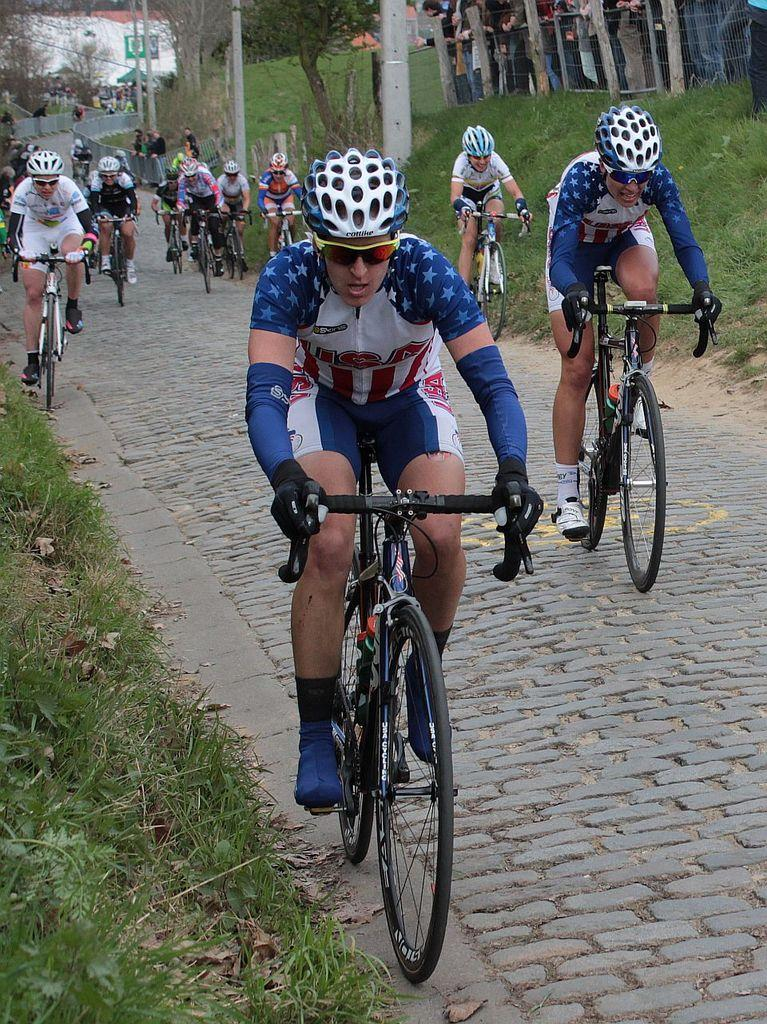How many people are in the image? There are people in the image, but the exact number is not specified. What are some of the people doing in the image? Some people are riding bicycles in the image. What can be seen in the image besides the people and bicycles? There are poles, sign boards, grass, trees, and leaves on the ground in the image. What is the income of the mother in the image? There is no mention of a mother or income in the image, so this question cannot be answered. 